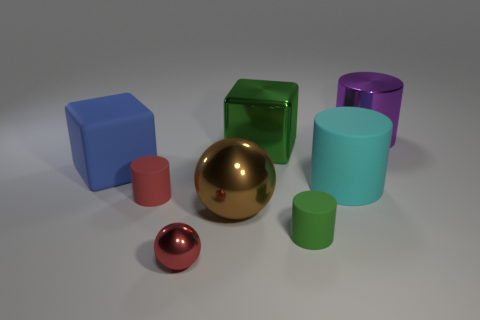Are there any yellow things that have the same material as the large purple thing?
Make the answer very short. No. Does the tiny cylinder that is right of the large metallic cube have the same material as the large cylinder that is in front of the big purple metallic object?
Offer a terse response. Yes. What number of cubes are there?
Provide a succinct answer. 2. What is the shape of the metallic thing that is to the right of the small green object?
Give a very brief answer. Cylinder. What number of other things are the same size as the rubber cube?
Provide a short and direct response. 4. Is the shape of the red object that is in front of the brown metal ball the same as the tiny matte object that is on the left side of the big brown thing?
Provide a succinct answer. No. How many rubber cylinders are in front of the large brown shiny sphere?
Your response must be concise. 1. What is the color of the large cylinder that is behind the matte block?
Provide a short and direct response. Purple. There is another metal thing that is the same shape as the large cyan object; what is its color?
Give a very brief answer. Purple. Is there any other thing that has the same color as the large rubber cube?
Give a very brief answer. No. 